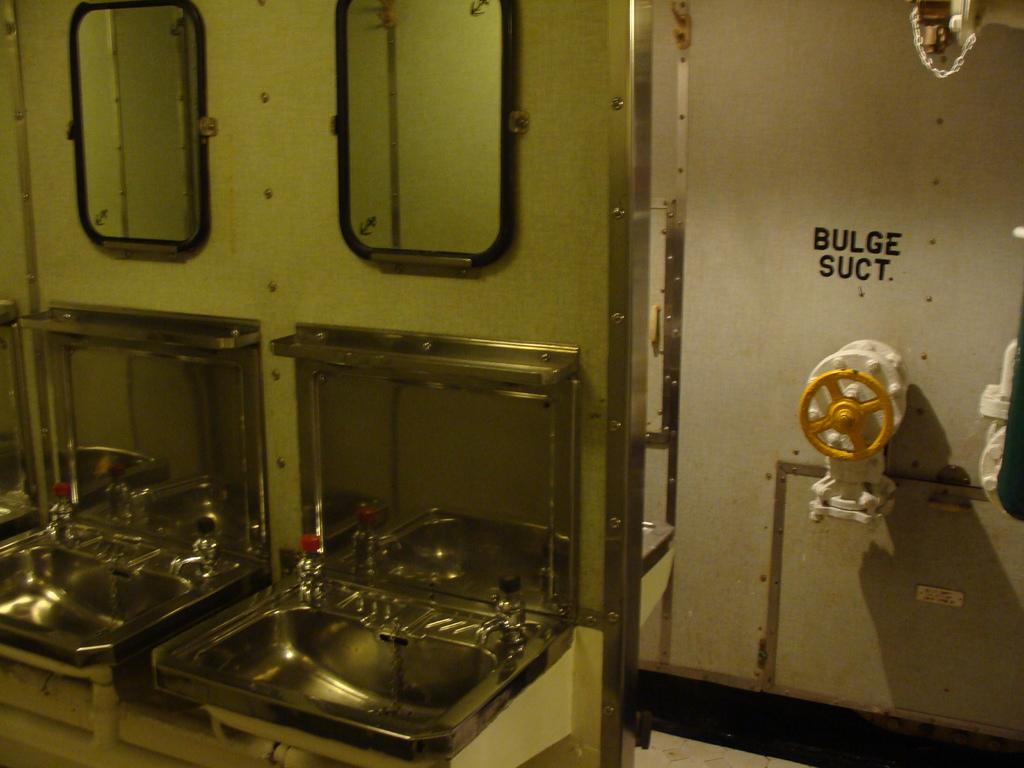What is the black print above the valve for?
Give a very brief answer. Bulge suct. What are the words above the turnoff valve ?
Make the answer very short. Bulge suct. 